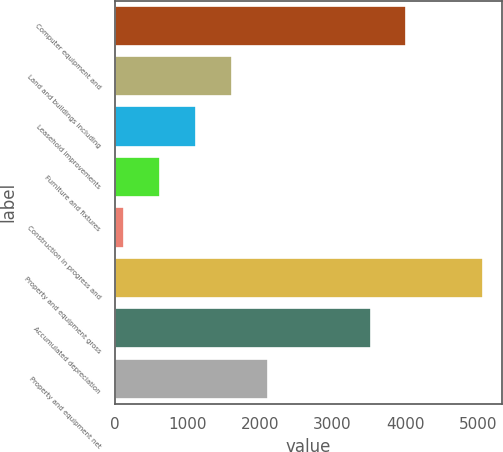Convert chart to OTSL. <chart><loc_0><loc_0><loc_500><loc_500><bar_chart><fcel>Computer equipment and<fcel>Land and buildings including<fcel>Leasehold improvements<fcel>Furniture and fixtures<fcel>Construction in progress and<fcel>Property and equipment gross<fcel>Accumulated depreciation<fcel>Property and equipment net<nl><fcel>4018.7<fcel>1615.1<fcel>1120.4<fcel>625.7<fcel>131<fcel>5078<fcel>3524<fcel>2109.8<nl></chart> 